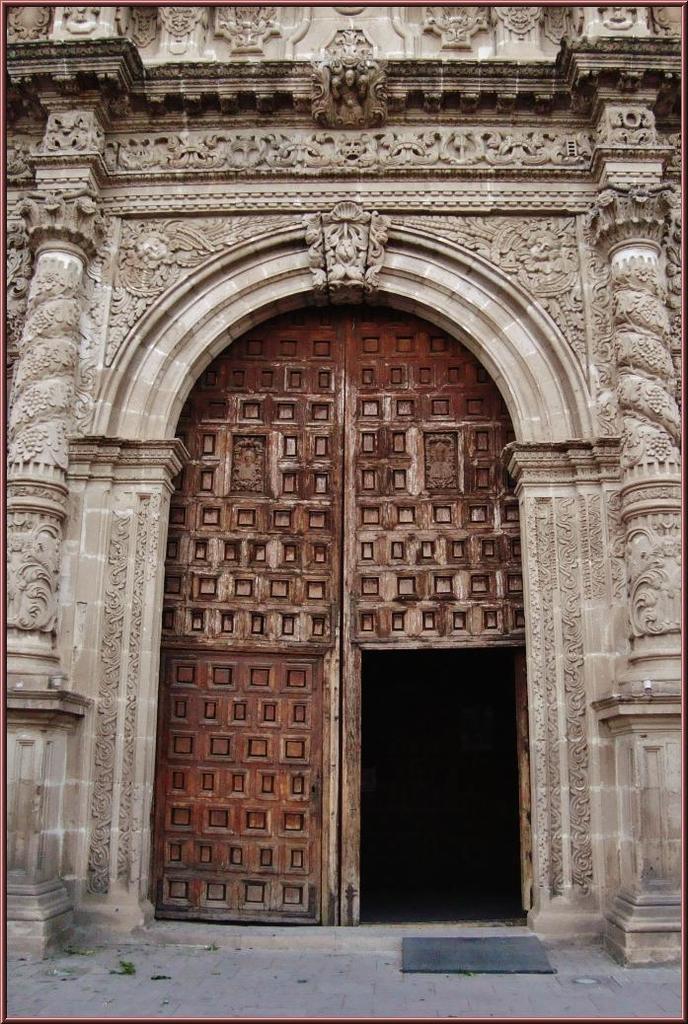Can you describe this image briefly? This is an edited picture. I can see a wall with pillars and a door. 